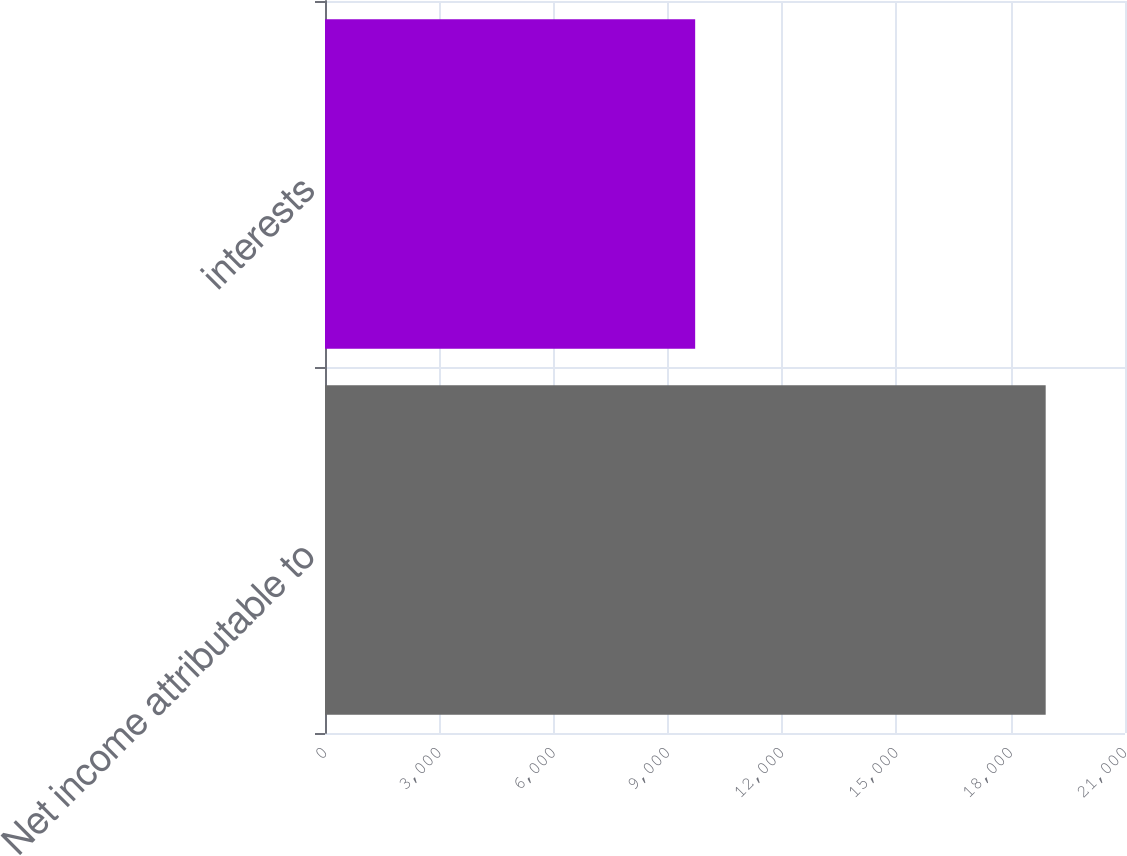Convert chart. <chart><loc_0><loc_0><loc_500><loc_500><bar_chart><fcel>Net income attributable to<fcel>interests<nl><fcel>18918<fcel>9717<nl></chart> 